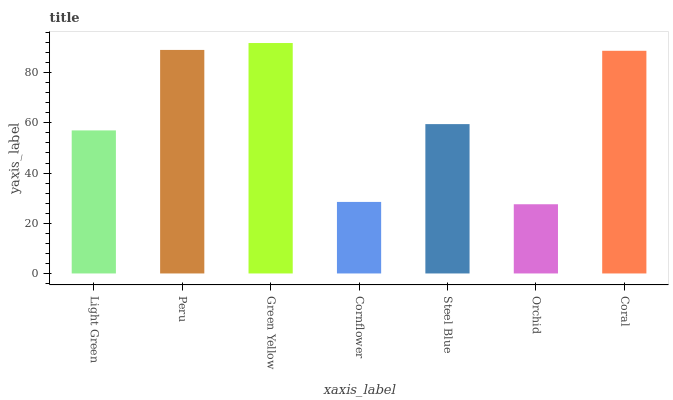Is Orchid the minimum?
Answer yes or no. Yes. Is Green Yellow the maximum?
Answer yes or no. Yes. Is Peru the minimum?
Answer yes or no. No. Is Peru the maximum?
Answer yes or no. No. Is Peru greater than Light Green?
Answer yes or no. Yes. Is Light Green less than Peru?
Answer yes or no. Yes. Is Light Green greater than Peru?
Answer yes or no. No. Is Peru less than Light Green?
Answer yes or no. No. Is Steel Blue the high median?
Answer yes or no. Yes. Is Steel Blue the low median?
Answer yes or no. Yes. Is Green Yellow the high median?
Answer yes or no. No. Is Orchid the low median?
Answer yes or no. No. 